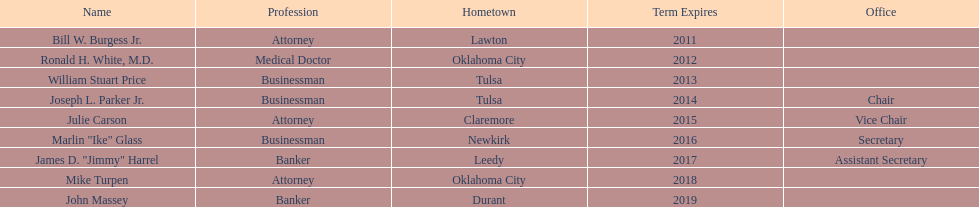I'm looking to parse the entire table for insights. Could you assist me with that? {'header': ['Name', 'Profession', 'Hometown', 'Term Expires', 'Office'], 'rows': [['Bill W. Burgess Jr.', 'Attorney', 'Lawton', '2011', ''], ['Ronald H. White, M.D.', 'Medical Doctor', 'Oklahoma City', '2012', ''], ['William Stuart Price', 'Businessman', 'Tulsa', '2013', ''], ['Joseph L. Parker Jr.', 'Businessman', 'Tulsa', '2014', 'Chair'], ['Julie Carson', 'Attorney', 'Claremore', '2015', 'Vice Chair'], ['Marlin "Ike" Glass', 'Businessman', 'Newkirk', '2016', 'Secretary'], ['James D. "Jimmy" Harrel', 'Banker', 'Leedy', '2017', 'Assistant Secretary'], ['Mike Turpen', 'Attorney', 'Oklahoma City', '2018', ''], ['John Massey', 'Banker', 'Durant', '2019', '']]} Total count of members from lawton and oklahoma city 3. 